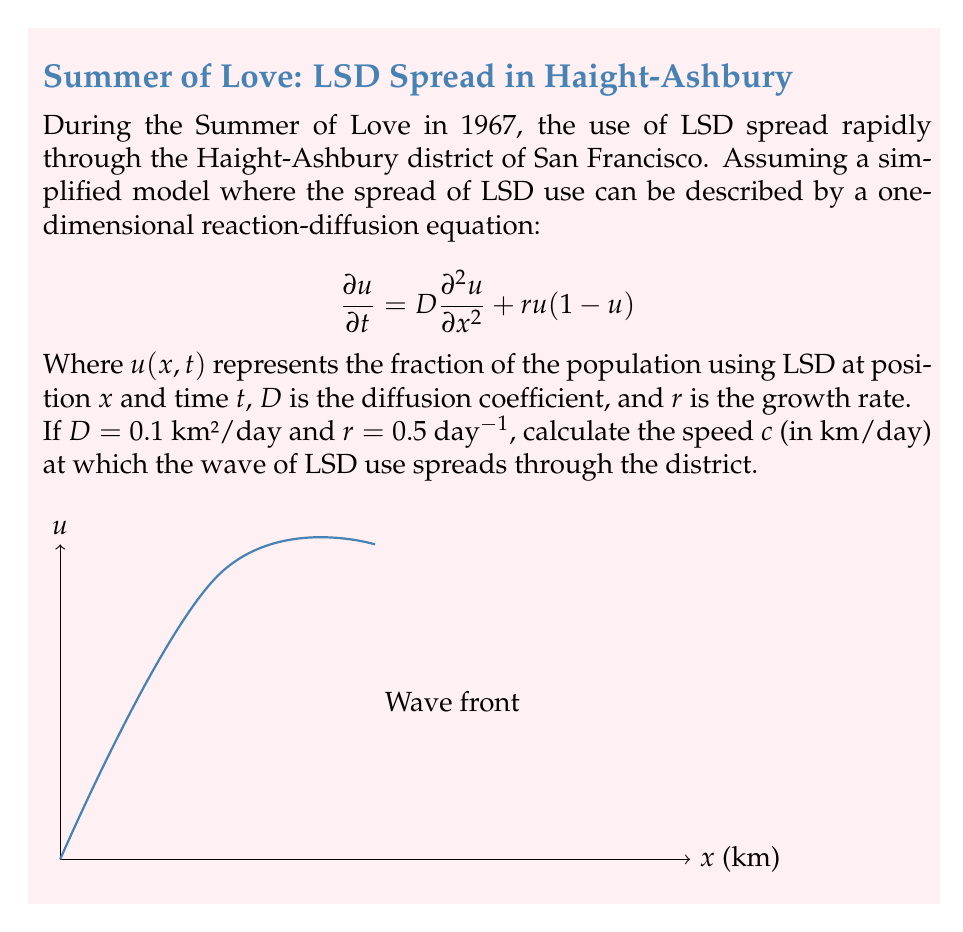Help me with this question. To solve this problem, we'll use the formula for the speed of propagation in a reaction-diffusion equation, also known as the Fisher-Kolmogorov equation:

1) The speed $c$ of the traveling wave solution is given by:

   $$c = 2\sqrt{Dr}$$

2) We're given:
   $D = 0.1$ km²/day (diffusion coefficient)
   $r = 0.5$ day⁻¹ (growth rate)

3) Substituting these values into the formula:

   $$c = 2\sqrt{(0.1)(0.5)}$$

4) Simplify under the square root:

   $$c = 2\sqrt{0.05}$$

5) Calculate the square root:

   $$c = 2(0.2236)$$

6) Multiply:

   $$c = 0.4472$$ km/day

This result represents the speed at which the wave of LSD use spreads through the Haight-Ashbury district, according to this simplified model.
Answer: $0.4472$ km/day 